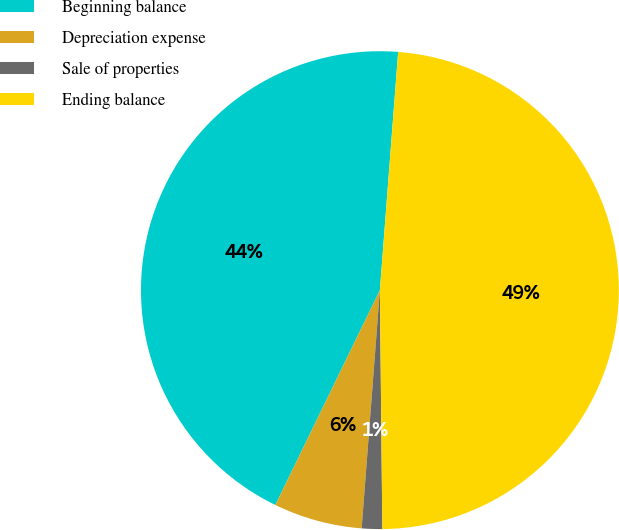Convert chart to OTSL. <chart><loc_0><loc_0><loc_500><loc_500><pie_chart><fcel>Beginning balance<fcel>Depreciation expense<fcel>Sale of properties<fcel>Ending balance<nl><fcel>44.01%<fcel>5.99%<fcel>1.38%<fcel>48.62%<nl></chart> 